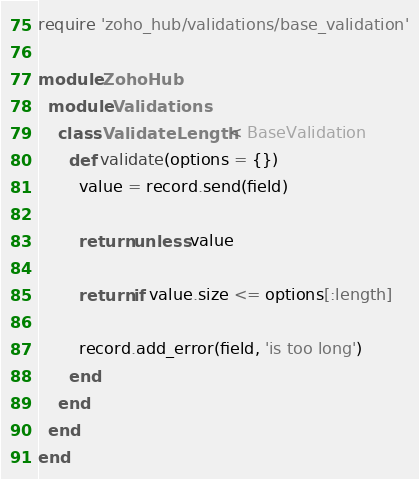Convert code to text. <code><loc_0><loc_0><loc_500><loc_500><_Ruby_>require 'zoho_hub/validations/base_validation'

module ZohoHub
  module Validations
    class ValidateLength < BaseValidation
      def validate(options = {})
        value = record.send(field)

        return unless value

        return if value.size <= options[:length]

        record.add_error(field, 'is too long')
      end
    end
  end
end
</code> 